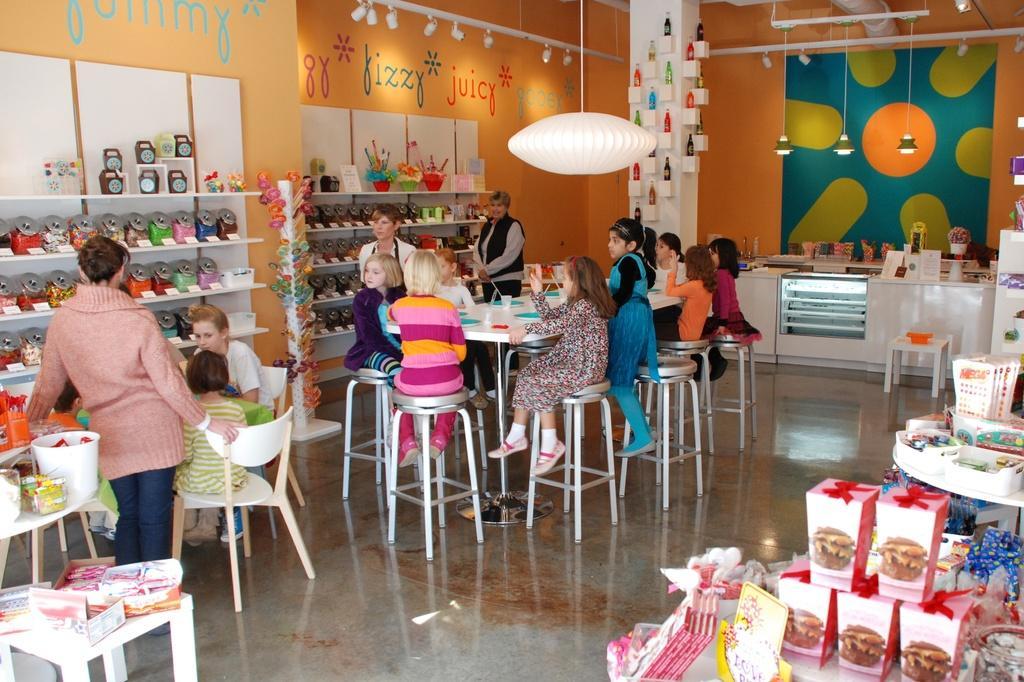Describe this image in one or two sentences. This is a food court. So many kids are sitting on the stool. There is a table and stools. And one girl wearing green and white dress is sitting on the chair. Beside her one lady is sitting. And a lady is standing wearing a jacket. On the cupboard there are many items kept. There are lollipops on the stand. On the wall there is written something. And they decorated the walls with bottles. And there are standing lamps. And on the table there are many items kept. 